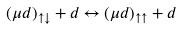Convert formula to latex. <formula><loc_0><loc_0><loc_500><loc_500>( \mu d ) _ { \uparrow \downarrow } + d \leftrightarrow ( \mu d ) _ { \uparrow \uparrow } + d</formula> 